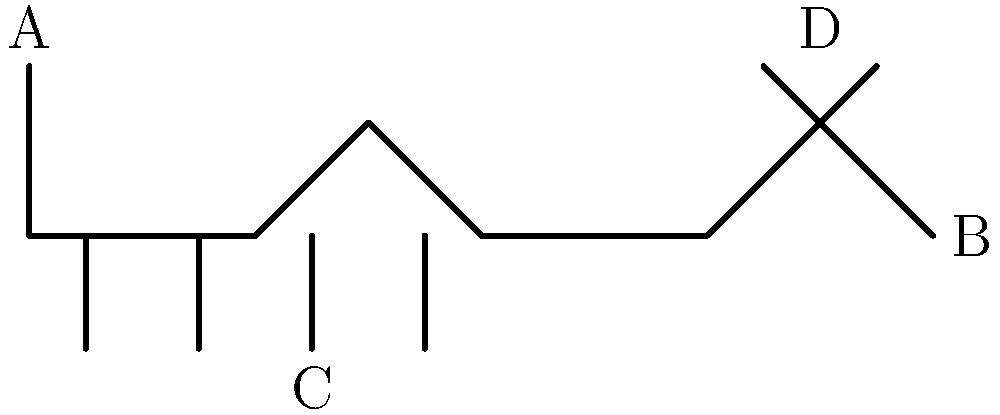Based on the stick figure illustration of a dog, which labeled part (A, B, C, or D) is most likely to indicate alertness or interest during a detection training session? To answer this question, we need to consider the body language signals of dogs during detection training:

1. Tail (A): A raised tail often indicates alertness or interest. In detection dogs, a high, wagging tail can signal that they've picked up a scent or are actively searching.

2. Nose (B): While the nose is crucial for detection, its position alone doesn't necessarily indicate alertness or interest.

3. Legs (C): The position of the legs can indicate tension or readiness to move, but they're not the primary indicator of alertness or interest in this context.

4. Ears (D): Erect, forward-facing ears are one of the clearest signs of alertness and interest in dogs. During detection training, dogs will often perk up their ears when they detect a target odor or are focused on a task.

Given these considerations, the ears (D) are the most reliable indicator of alertness or interest during a detection training session. They're often the first part of a dog's body to respond to stimuli and can provide clear signals about the dog's level of engagement and focus.
Answer: D (Ears) 